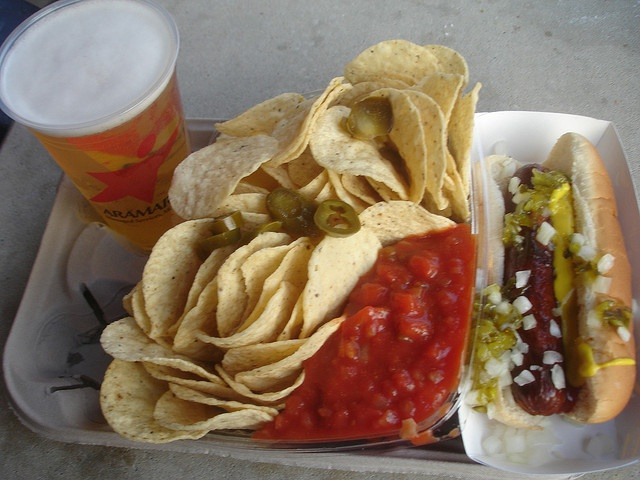Describe the objects in this image and their specific colors. I can see dining table in navy, darkgray, gray, black, and lightgray tones, hot dog in navy, tan, maroon, olive, and darkgray tones, and cup in navy, darkgray, and maroon tones in this image. 